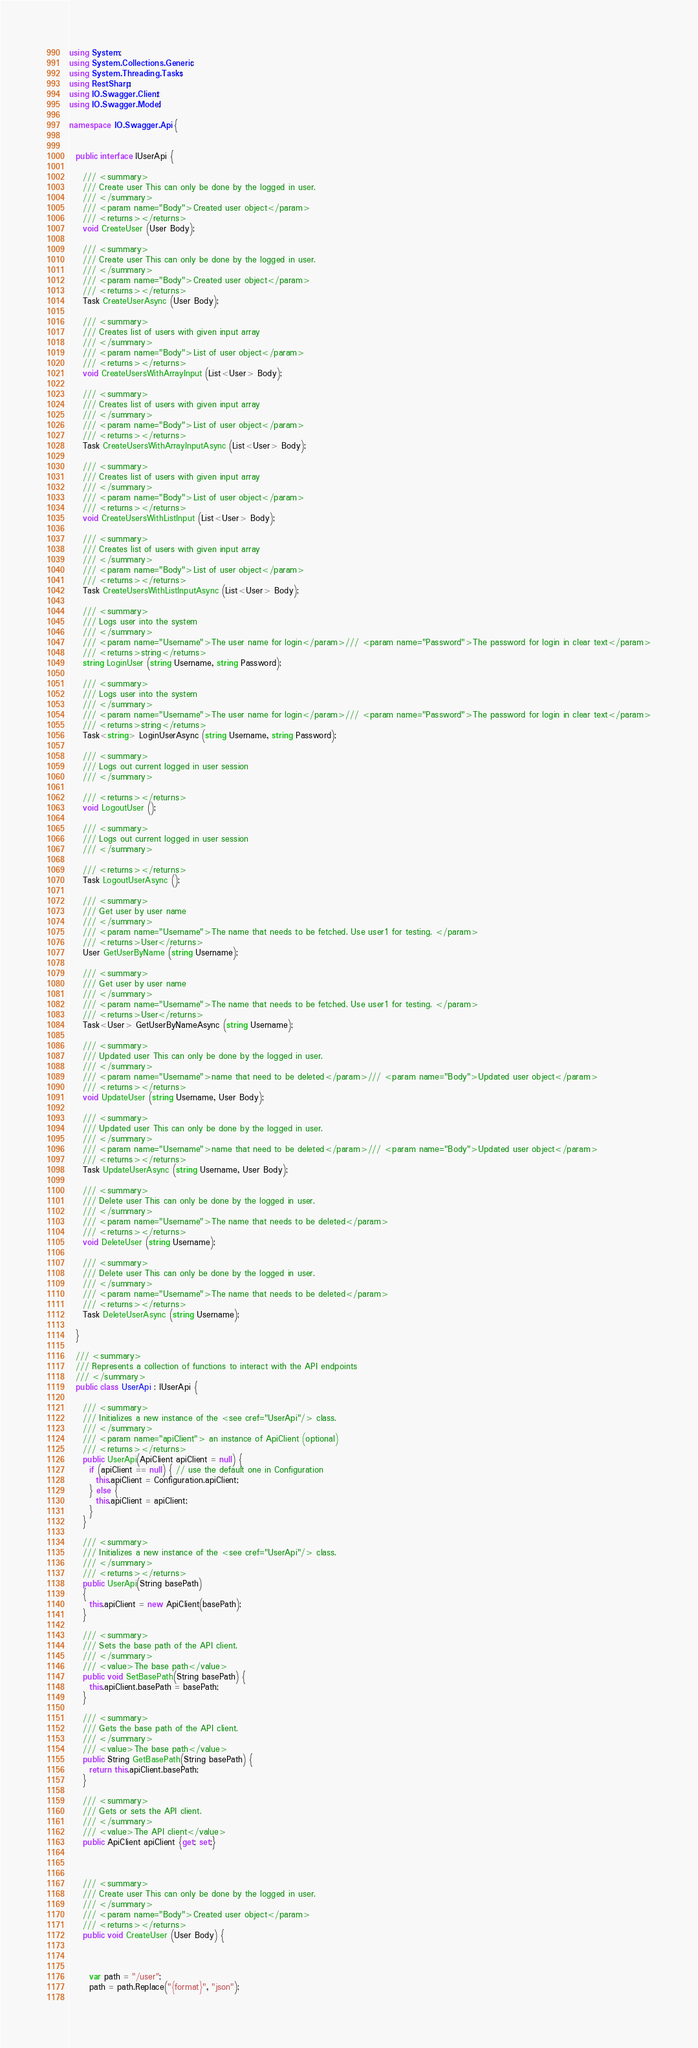Convert code to text. <code><loc_0><loc_0><loc_500><loc_500><_C#_>using System;
using System.Collections.Generic;
using System.Threading.Tasks;
using RestSharp;
using IO.Swagger.Client;
using IO.Swagger.Model;

namespace IO.Swagger.Api {
  

  public interface IUserApi {
    
    /// <summary>
    /// Create user This can only be done by the logged in user.
    /// </summary>
    /// <param name="Body">Created user object</param>
    /// <returns></returns>
    void CreateUser (User Body);

    /// <summary>
    /// Create user This can only be done by the logged in user.
    /// </summary>
    /// <param name="Body">Created user object</param>
    /// <returns></returns>
    Task CreateUserAsync (User Body);
    
    /// <summary>
    /// Creates list of users with given input array 
    /// </summary>
    /// <param name="Body">List of user object</param>
    /// <returns></returns>
    void CreateUsersWithArrayInput (List<User> Body);

    /// <summary>
    /// Creates list of users with given input array 
    /// </summary>
    /// <param name="Body">List of user object</param>
    /// <returns></returns>
    Task CreateUsersWithArrayInputAsync (List<User> Body);
    
    /// <summary>
    /// Creates list of users with given input array 
    /// </summary>
    /// <param name="Body">List of user object</param>
    /// <returns></returns>
    void CreateUsersWithListInput (List<User> Body);

    /// <summary>
    /// Creates list of users with given input array 
    /// </summary>
    /// <param name="Body">List of user object</param>
    /// <returns></returns>
    Task CreateUsersWithListInputAsync (List<User> Body);
    
    /// <summary>
    /// Logs user into the system 
    /// </summary>
    /// <param name="Username">The user name for login</param>/// <param name="Password">The password for login in clear text</param>
    /// <returns>string</returns>
    string LoginUser (string Username, string Password);

    /// <summary>
    /// Logs user into the system 
    /// </summary>
    /// <param name="Username">The user name for login</param>/// <param name="Password">The password for login in clear text</param>
    /// <returns>string</returns>
    Task<string> LoginUserAsync (string Username, string Password);
    
    /// <summary>
    /// Logs out current logged in user session 
    /// </summary>
    
    /// <returns></returns>
    void LogoutUser ();

    /// <summary>
    /// Logs out current logged in user session 
    /// </summary>
    
    /// <returns></returns>
    Task LogoutUserAsync ();
    
    /// <summary>
    /// Get user by user name 
    /// </summary>
    /// <param name="Username">The name that needs to be fetched. Use user1 for testing. </param>
    /// <returns>User</returns>
    User GetUserByName (string Username);

    /// <summary>
    /// Get user by user name 
    /// </summary>
    /// <param name="Username">The name that needs to be fetched. Use user1 for testing. </param>
    /// <returns>User</returns>
    Task<User> GetUserByNameAsync (string Username);
    
    /// <summary>
    /// Updated user This can only be done by the logged in user.
    /// </summary>
    /// <param name="Username">name that need to be deleted</param>/// <param name="Body">Updated user object</param>
    /// <returns></returns>
    void UpdateUser (string Username, User Body);

    /// <summary>
    /// Updated user This can only be done by the logged in user.
    /// </summary>
    /// <param name="Username">name that need to be deleted</param>/// <param name="Body">Updated user object</param>
    /// <returns></returns>
    Task UpdateUserAsync (string Username, User Body);
    
    /// <summary>
    /// Delete user This can only be done by the logged in user.
    /// </summary>
    /// <param name="Username">The name that needs to be deleted</param>
    /// <returns></returns>
    void DeleteUser (string Username);

    /// <summary>
    /// Delete user This can only be done by the logged in user.
    /// </summary>
    /// <param name="Username">The name that needs to be deleted</param>
    /// <returns></returns>
    Task DeleteUserAsync (string Username);
    
  }

  /// <summary>
  /// Represents a collection of functions to interact with the API endpoints
  /// </summary>
  public class UserApi : IUserApi {

    /// <summary>
    /// Initializes a new instance of the <see cref="UserApi"/> class.
    /// </summary>
    /// <param name="apiClient"> an instance of ApiClient (optional)
    /// <returns></returns>
    public UserApi(ApiClient apiClient = null) {
      if (apiClient == null) { // use the default one in Configuration
        this.apiClient = Configuration.apiClient; 
      } else {
        this.apiClient = apiClient;
      }
    }

    /// <summary>
    /// Initializes a new instance of the <see cref="UserApi"/> class.
    /// </summary>
    /// <returns></returns>
    public UserApi(String basePath)
    {
      this.apiClient = new ApiClient(basePath);
    }

    /// <summary>
    /// Sets the base path of the API client.
    /// </summary>
    /// <value>The base path</value>
    public void SetBasePath(String basePath) {
      this.apiClient.basePath = basePath;
    }

    /// <summary>
    /// Gets the base path of the API client.
    /// </summary>
    /// <value>The base path</value>
    public String GetBasePath(String basePath) {
      return this.apiClient.basePath;
    }

    /// <summary>
    /// Gets or sets the API client.
    /// </summary>
    /// <value>The API client</value>
    public ApiClient apiClient {get; set;}


    
    /// <summary>
    /// Create user This can only be done by the logged in user.
    /// </summary>
    /// <param name="Body">Created user object</param>
    /// <returns></returns>
    public void CreateUser (User Body) {

      

      var path = "/user";
      path = path.Replace("{format}", "json");
      
</code> 